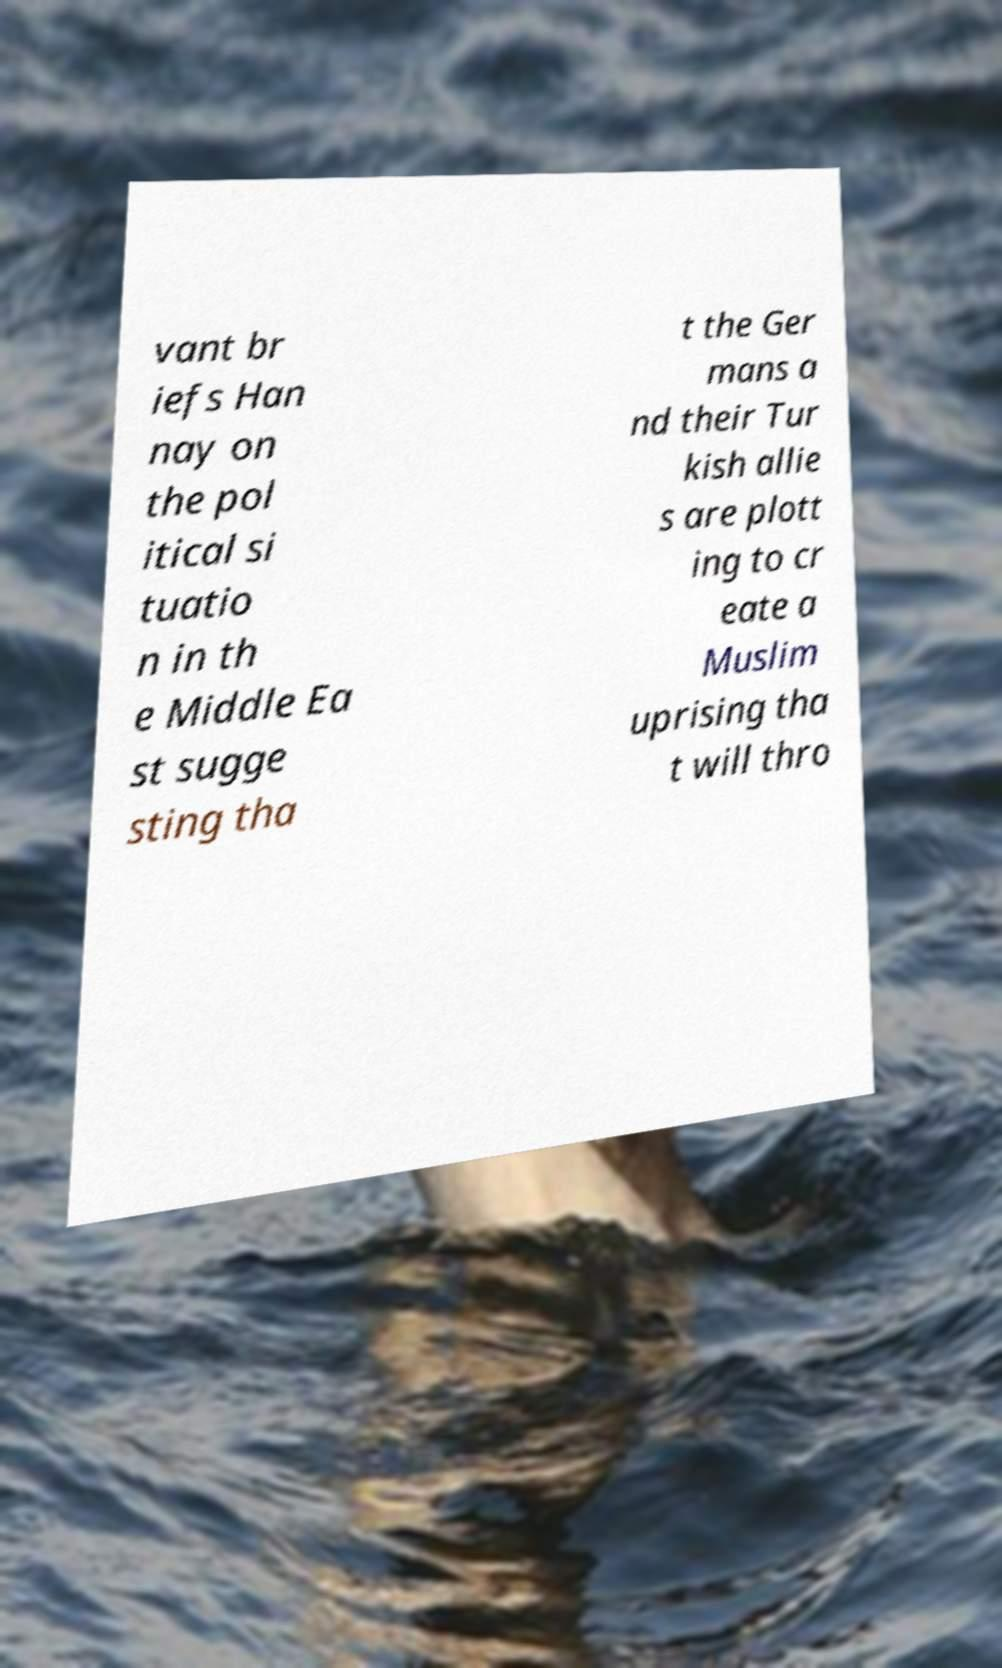Please read and relay the text visible in this image. What does it say? vant br iefs Han nay on the pol itical si tuatio n in th e Middle Ea st sugge sting tha t the Ger mans a nd their Tur kish allie s are plott ing to cr eate a Muslim uprising tha t will thro 